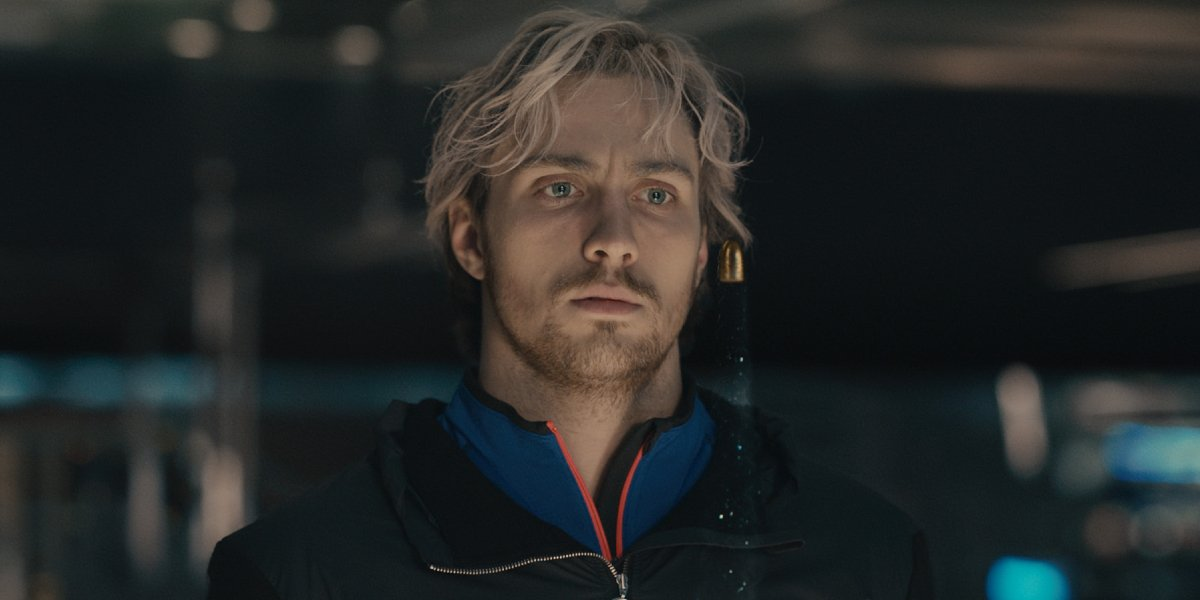Describe the setting and mood. The setting of the image seems to be in a dimly lit room, possibly a store or a mall, suggested by the blurred shapes and colors in the background indicative of a bustling environment. The mood is one of quiet intensity and contemplation, as implied by the focused gaze and serious expression of the man at the center of the image. The soft ambient lighting adds a touch of warmth to the otherwise muted colors of the scene. 